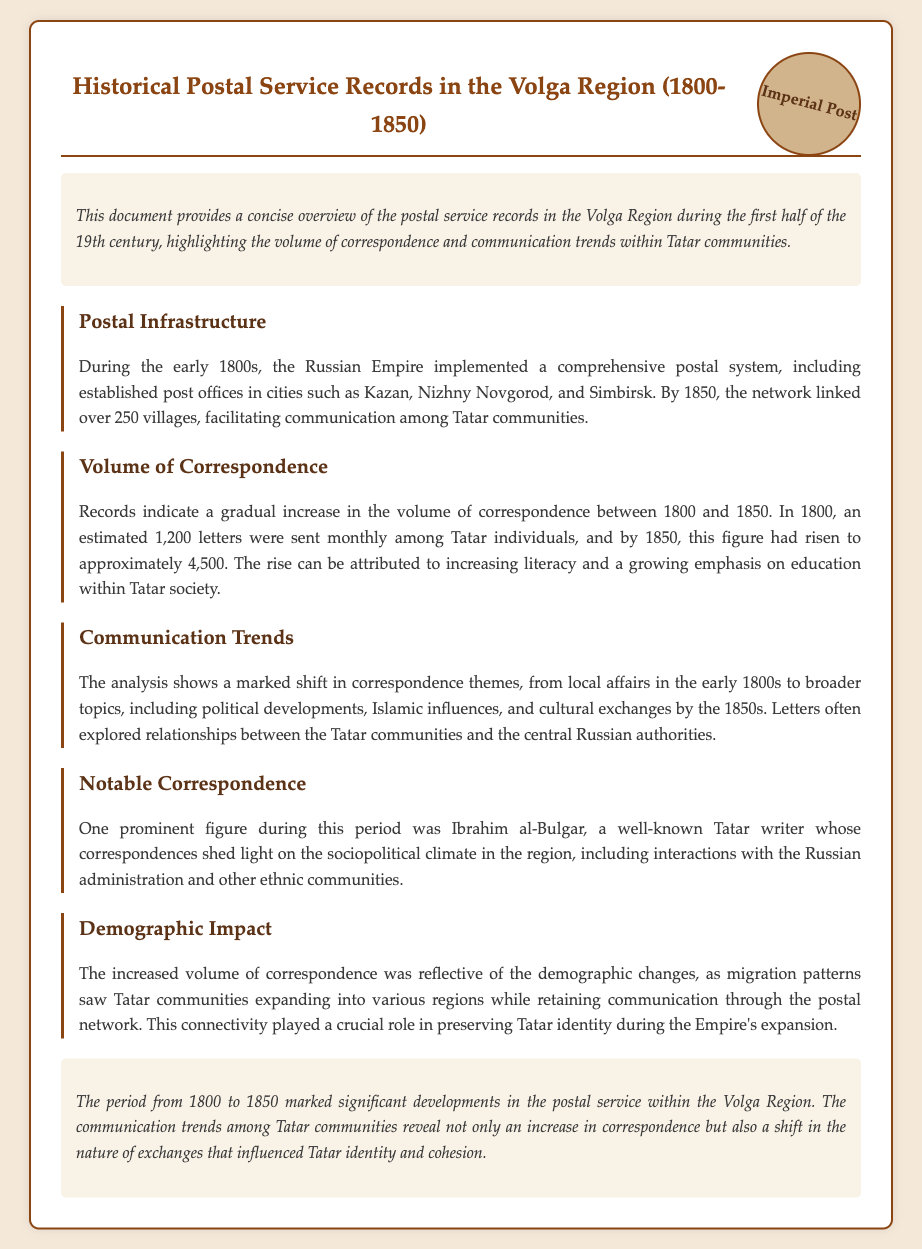what years does the document cover? The document outlines the historical postal service records from 1800 to 1850, indicating the timeline of the study.
Answer: 1800-1850 how many letters were sent monthly among Tatar individuals in 1800? The document states that in 1800, approximately 1,200 letters were sent monthly among Tatar individuals, providing a specific figure for that year.
Answer: 1,200 what was the estimated volume of letters sent by 1850? The document mentions that by 1850, the volume of correspondence had risen to around 4,500 letters monthly, suggesting a significant increase over time.
Answer: 4,500 who was a prominent figure in Tatar correspondence during this period? The document highlights Ibrahim al-Bulgar as a notable correspondent, indicating his significance in the context of Tatar communication.
Answer: Ibrahim al-Bulgar what themes shifted in correspondence by the 1850s? The analysis in the document shows that correspondence themes shifted to include broader topics such as political developments and cultural exchanges.
Answer: Political developments how did literacy influence correspondence volume? The document suggests that increasing literacy and a growing emphasis on education within Tatar society contributed to the rise in correspondence volume.
Answer: Increasing literacy what role did the postal network play in Tatar identity? The document discusses how connectivity through the postal network was crucial in preserving Tatar identity amid demographic changes.
Answer: Preserving Tatar identity how many villages were linked by the postal network by 1850? The document states that by 1850, over 250 villages were connected through the postal network in the Volga Region, indicating the extent of the postal service.
Answer: Over 250 villages 